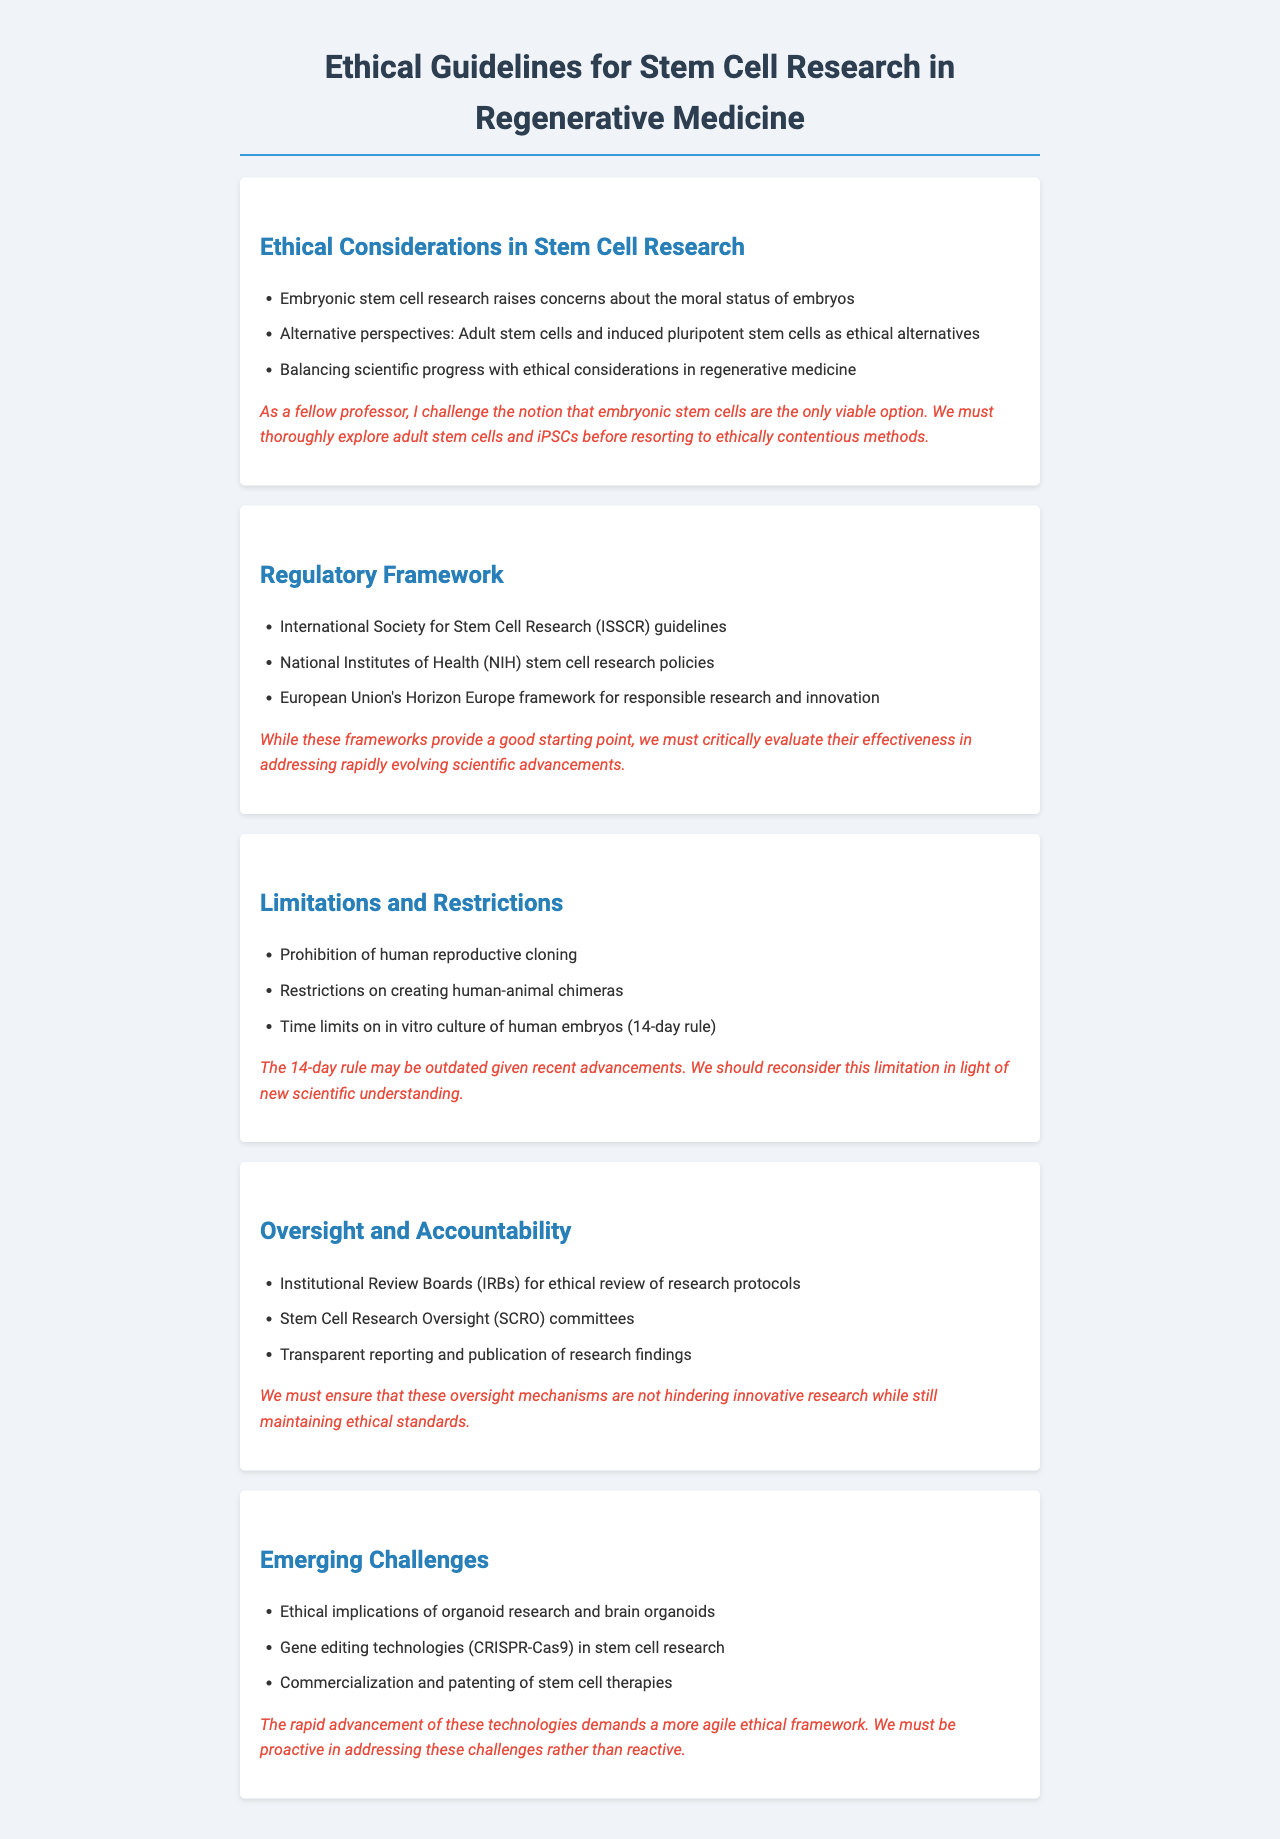What are the ethical concerns associated with embryonic stem cell research? The document states that embryonic stem cell research raises concerns about the moral status of embryos.
Answer: Moral status of embryos What are two ethical alternatives to embryonic stem cells mentioned? The document highlights adult stem cells and induced pluripotent stem cells as ethical alternatives.
Answer: Adult stem cells and induced pluripotent stem cells What is the time limit for in vitro culture of human embryos referred to in the document? The document refers to the "14-day rule" as the time limit on in vitro culture of human embryos.
Answer: 14-day rule Which organization provides guidelines for stem cell research mentioned in the document? The document mentions the International Society for Stem Cell Research (ISSCR) as providing guidelines.
Answer: International Society for Stem Cell Research (ISSCR) What challenge does the document raise regarding current oversight mechanisms? The document challenges whether oversight mechanisms are hindering innovative research while maintaining ethical standards.
Answer: Hindering innovative research What emerging challenge related to gene editing technologies is mentioned? The document discusses gene editing technologies (CRISPR-Cas9) as an emerging challenge in stem cell research.
Answer: Gene editing technologies (CRISPR-Cas9) What ethical implications are associated with brain organoids? The document mentions ethical implications specifically related to organoid research and brain organoids without detail.
Answer: Ethical implications of organoid research and brain organoids What does the document suggest about the current regulatory frameworks for stem cell research? The document suggests critically evaluating the effectiveness of regulatory frameworks in addressing scientific advancements.
Answer: Effectiveness of regulatory frameworks 